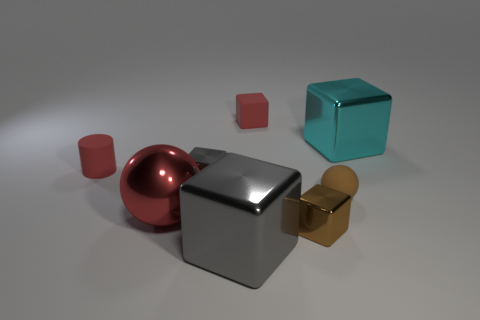Subtract all purple blocks. Subtract all brown spheres. How many blocks are left? 5 Add 2 tiny rubber objects. How many objects exist? 10 Subtract all spheres. How many objects are left? 6 Subtract 1 cyan blocks. How many objects are left? 7 Subtract all cyan cubes. Subtract all small rubber cubes. How many objects are left? 6 Add 8 red matte objects. How many red matte objects are left? 10 Add 6 tiny gray metal cubes. How many tiny gray metal cubes exist? 7 